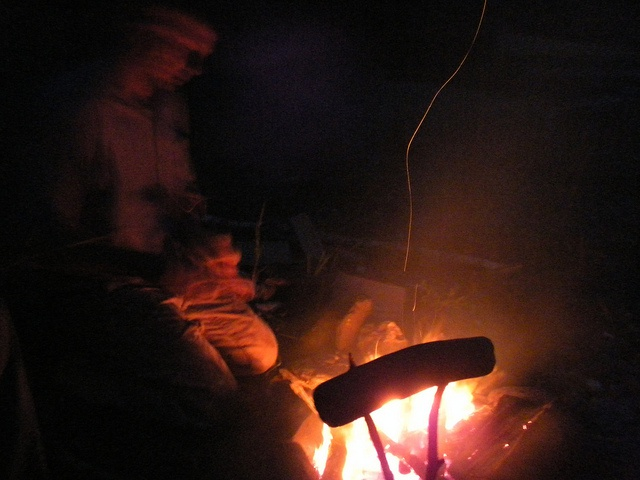Describe the objects in this image and their specific colors. I can see people in black, maroon, brown, and red tones and hot dog in black, maroon, and brown tones in this image. 